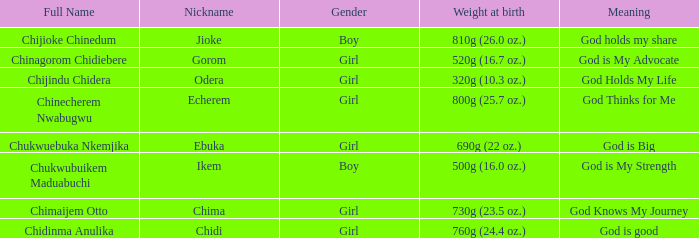What is the nickname of the boy who weighed 810g (26.0 oz.) at birth? Jioke. 